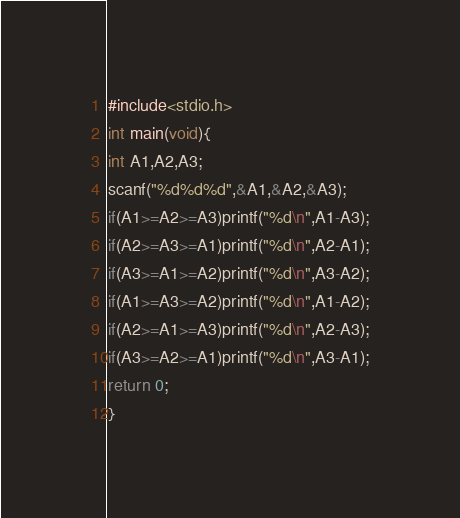<code> <loc_0><loc_0><loc_500><loc_500><_C_>#include<stdio.h>
int main(void){
int A1,A2,A3;
scanf("%d%d%d",&A1,&A2,&A3);
if(A1>=A2>=A3)printf("%d\n",A1-A3);
if(A2>=A3>=A1)printf("%d\n",A2-A1);
if(A3>=A1>=A2)printf("%d\n",A3-A2);
if(A1>=A3>=A2)printf("%d\n",A1-A2);
if(A2>=A1>=A3)printf("%d\n",A2-A3);
if(A3>=A2>=A1)printf("%d\n",A3-A1);
return 0;
}
</code> 